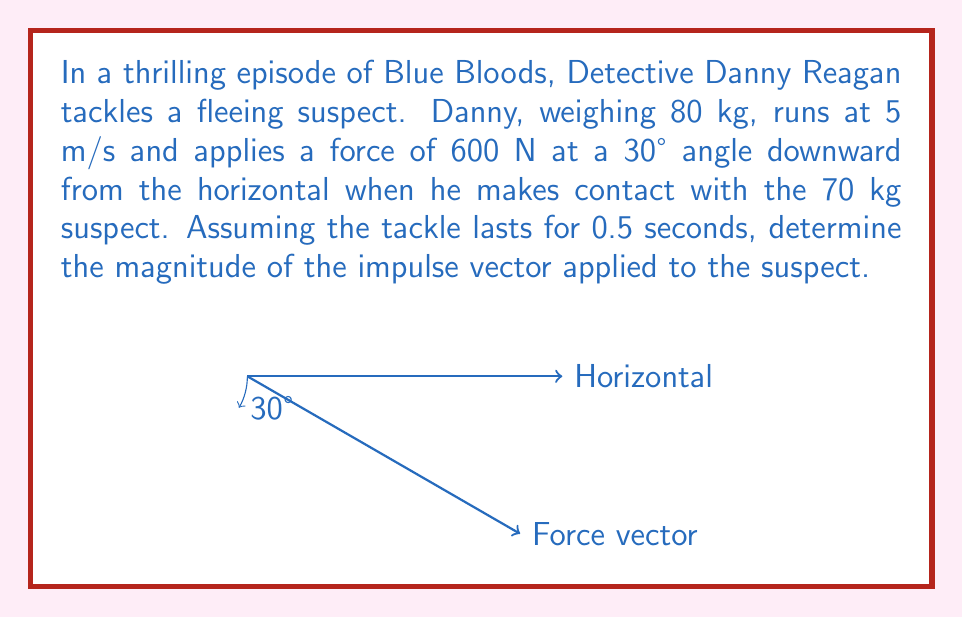Can you solve this math problem? Let's approach this step-by-step:

1) First, recall that impulse is defined as the product of force and time:

   $$ \vec{J} = \vec{F} \Delta t $$

2) We're given that the force is 600 N at a 30° angle downward from the horizontal. We can break this into components:

   $F_x = 600 \cos(30°) = 600 \cdot \frac{\sqrt{3}}{2} = 300\sqrt{3}$ N
   $F_y = -600 \sin(30°) = -600 \cdot \frac{1}{2} = -300$ N

3) So our force vector is:

   $$ \vec{F} = (300\sqrt{3}, -300) \text{ N} $$

4) The time duration of the tackle is 0.5 seconds. Multiplying each component by this time:

   $$ \vec{J} = (300\sqrt{3} \cdot 0.5, -300 \cdot 0.5) = (150\sqrt{3}, -150) \text{ N⋅s} $$

5) To find the magnitude of this impulse vector, we use the Pythagorean theorem:

   $$ |\vec{J}| = \sqrt{(150\sqrt{3})^2 + (-150)^2} = \sqrt{67500 + 22500} = \sqrt{90000} = 300 \text{ N⋅s} $$
Answer: 300 N⋅s 